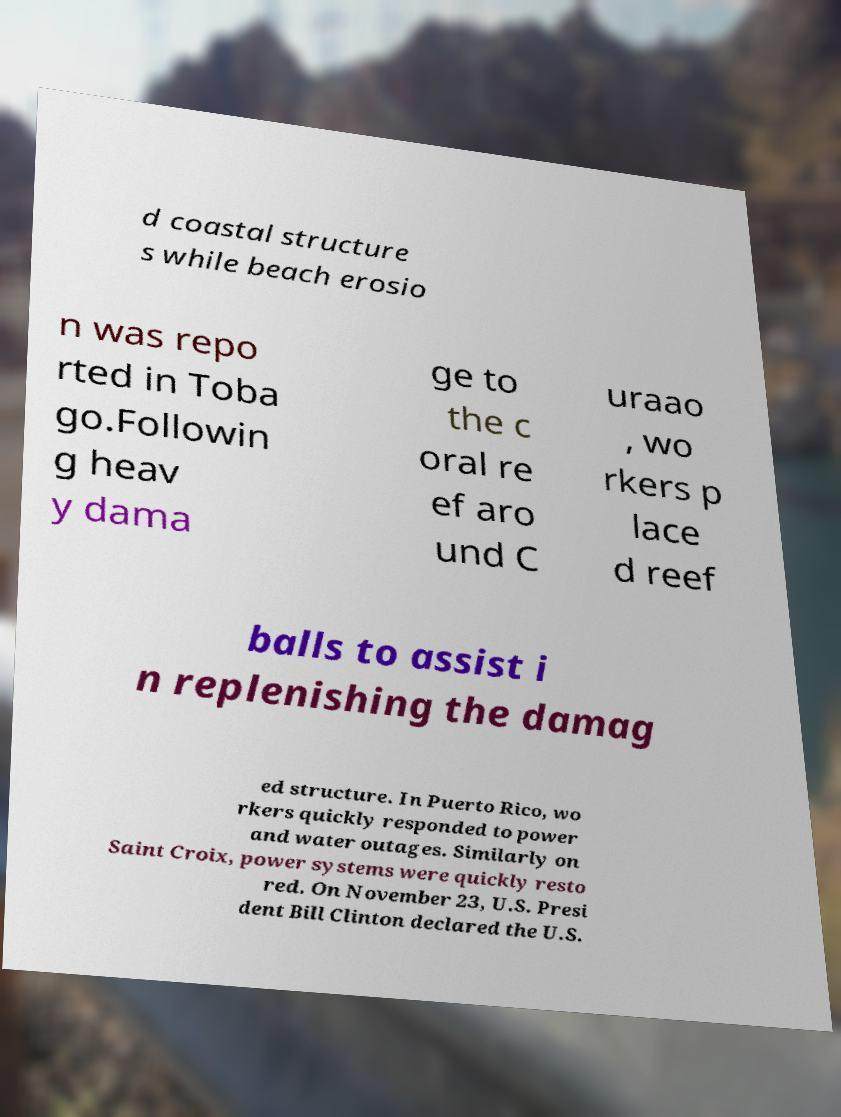Could you extract and type out the text from this image? d coastal structure s while beach erosio n was repo rted in Toba go.Followin g heav y dama ge to the c oral re ef aro und C uraao , wo rkers p lace d reef balls to assist i n replenishing the damag ed structure. In Puerto Rico, wo rkers quickly responded to power and water outages. Similarly on Saint Croix, power systems were quickly resto red. On November 23, U.S. Presi dent Bill Clinton declared the U.S. 